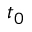<formula> <loc_0><loc_0><loc_500><loc_500>t _ { 0 }</formula> 